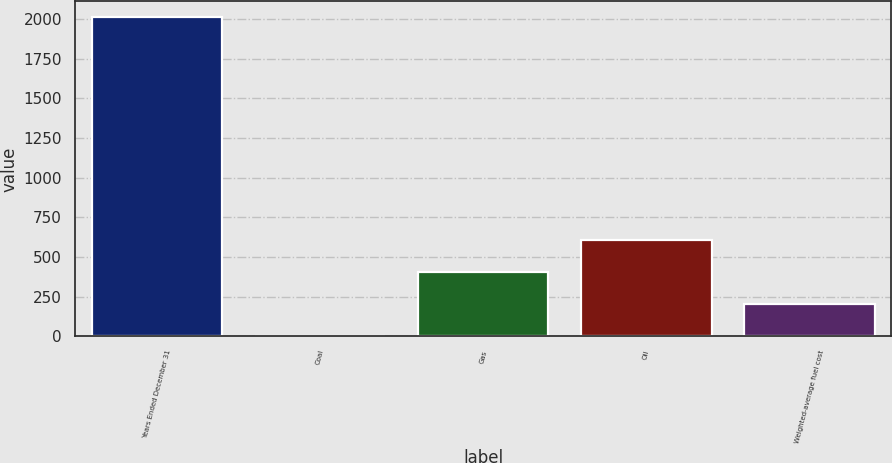Convert chart. <chart><loc_0><loc_0><loc_500><loc_500><bar_chart><fcel>Years Ended December 31<fcel>Coal<fcel>Gas<fcel>Oil<fcel>Weighted-average fuel cost<nl><fcel>2011<fcel>2.94<fcel>404.56<fcel>605.37<fcel>203.75<nl></chart> 